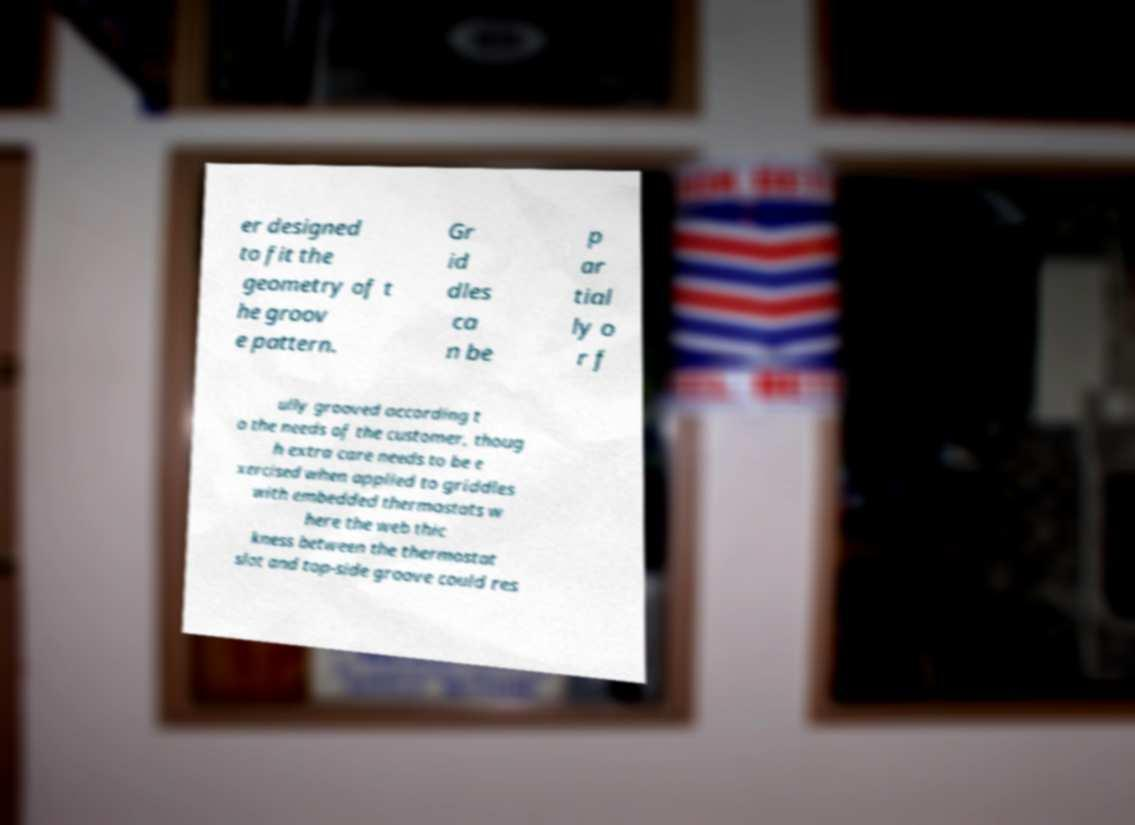What messages or text are displayed in this image? I need them in a readable, typed format. er designed to fit the geometry of t he groov e pattern. Gr id dles ca n be p ar tial ly o r f ully grooved according t o the needs of the customer, thoug h extra care needs to be e xercised when applied to griddles with embedded thermostats w here the web thic kness between the thermostat slot and top-side groove could res 